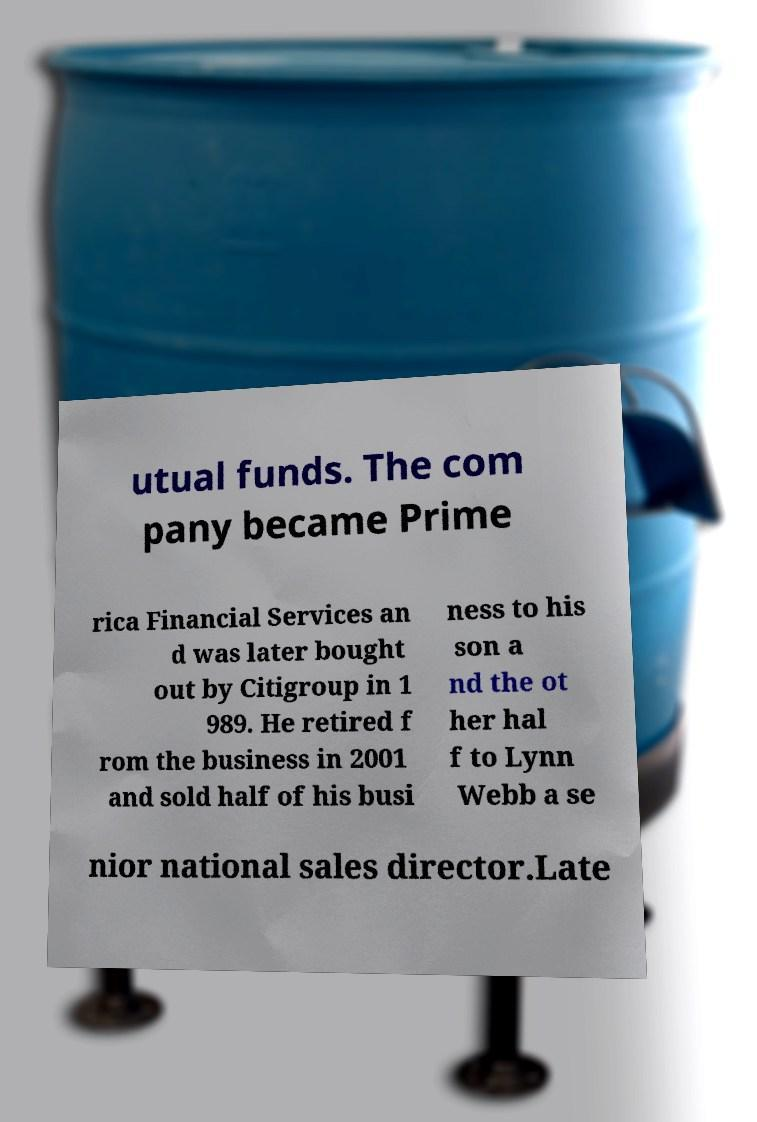Could you assist in decoding the text presented in this image and type it out clearly? utual funds. The com pany became Prime rica Financial Services an d was later bought out by Citigroup in 1 989. He retired f rom the business in 2001 and sold half of his busi ness to his son a nd the ot her hal f to Lynn Webb a se nior national sales director.Late 